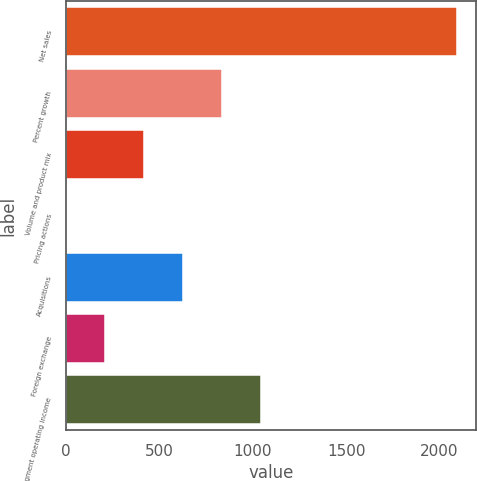<chart> <loc_0><loc_0><loc_500><loc_500><bar_chart><fcel>Net sales<fcel>Percent growth<fcel>Volume and product mix<fcel>Pricing actions<fcel>Acquisitions<fcel>Foreign exchange<fcel>Segment operating income<nl><fcel>2090.9<fcel>836.54<fcel>418.42<fcel>0.3<fcel>627.48<fcel>209.36<fcel>1045.6<nl></chart> 